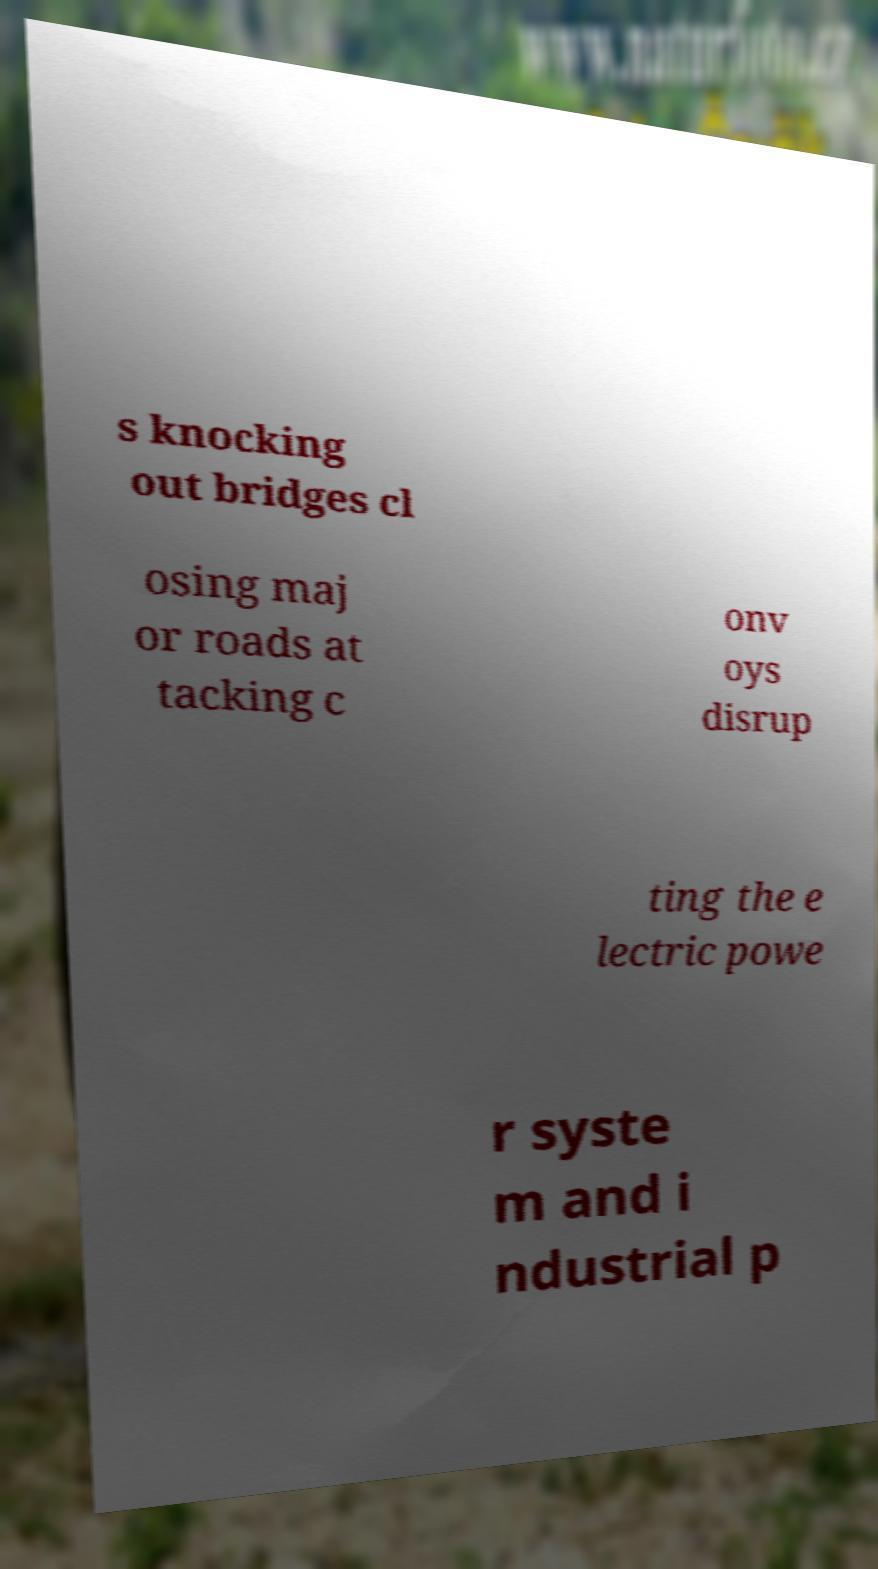Please identify and transcribe the text found in this image. s knocking out bridges cl osing maj or roads at tacking c onv oys disrup ting the e lectric powe r syste m and i ndustrial p 